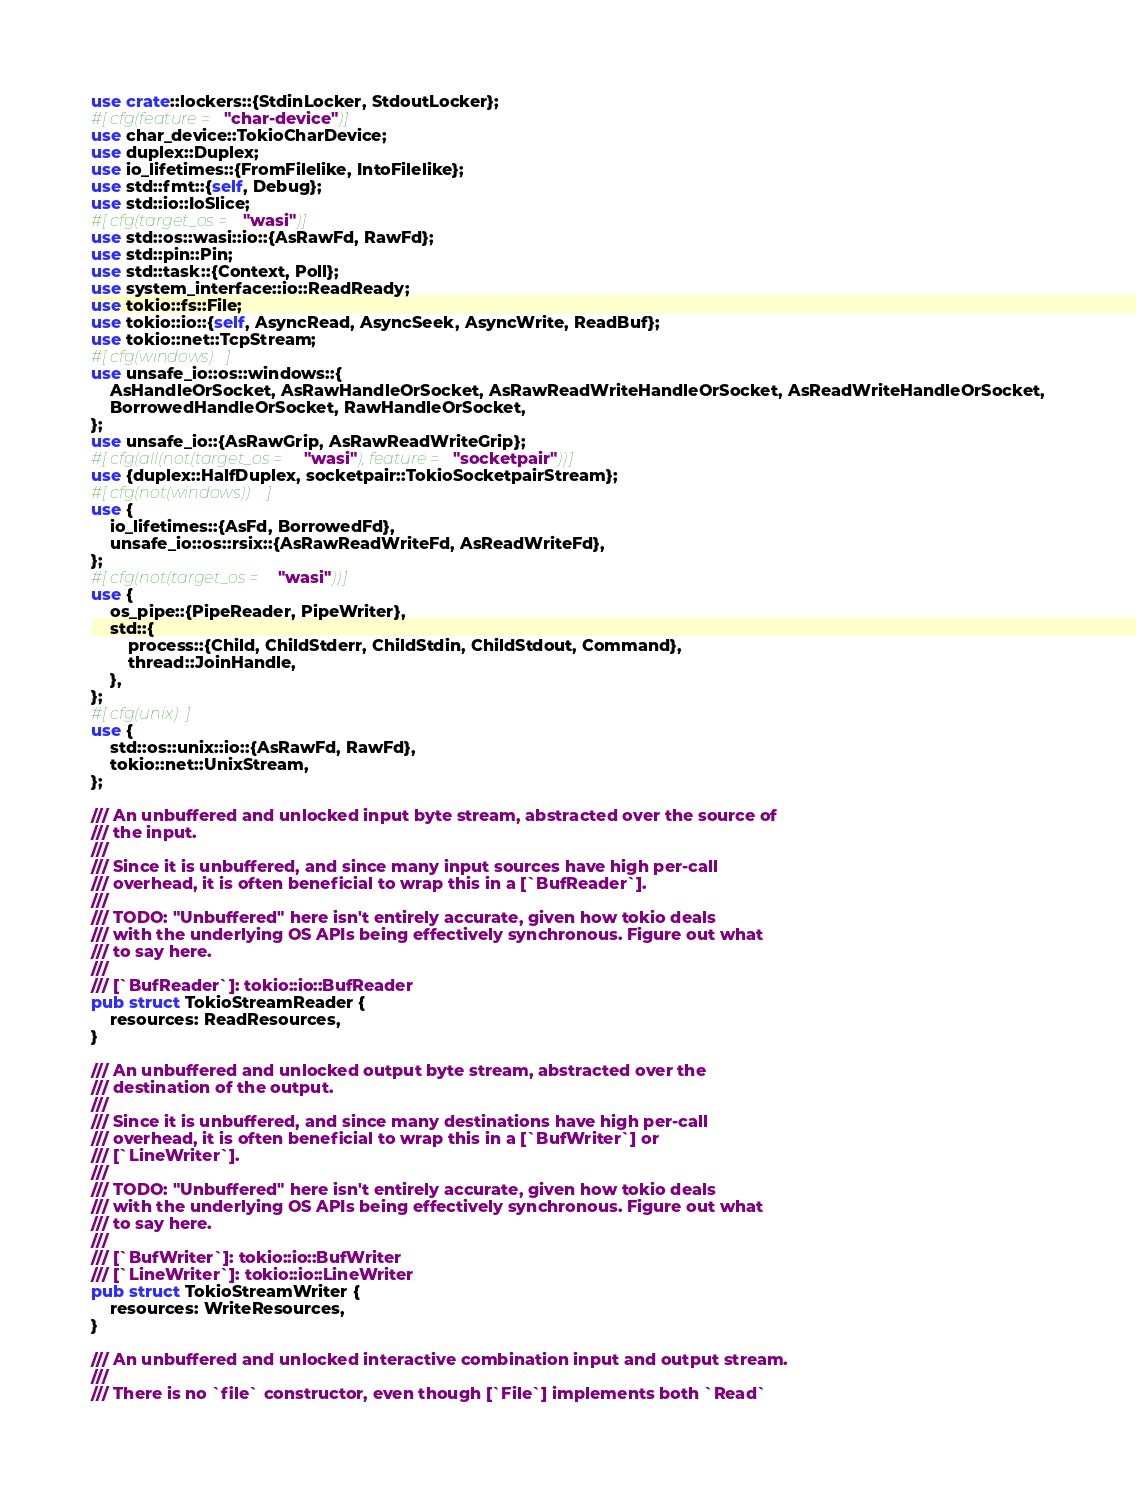<code> <loc_0><loc_0><loc_500><loc_500><_Rust_>use crate::lockers::{StdinLocker, StdoutLocker};
#[cfg(feature = "char-device")]
use char_device::TokioCharDevice;
use duplex::Duplex;
use io_lifetimes::{FromFilelike, IntoFilelike};
use std::fmt::{self, Debug};
use std::io::IoSlice;
#[cfg(target_os = "wasi")]
use std::os::wasi::io::{AsRawFd, RawFd};
use std::pin::Pin;
use std::task::{Context, Poll};
use system_interface::io::ReadReady;
use tokio::fs::File;
use tokio::io::{self, AsyncRead, AsyncSeek, AsyncWrite, ReadBuf};
use tokio::net::TcpStream;
#[cfg(windows)]
use unsafe_io::os::windows::{
    AsHandleOrSocket, AsRawHandleOrSocket, AsRawReadWriteHandleOrSocket, AsReadWriteHandleOrSocket,
    BorrowedHandleOrSocket, RawHandleOrSocket,
};
use unsafe_io::{AsRawGrip, AsRawReadWriteGrip};
#[cfg(all(not(target_os = "wasi"), feature = "socketpair"))]
use {duplex::HalfDuplex, socketpair::TokioSocketpairStream};
#[cfg(not(windows))]
use {
    io_lifetimes::{AsFd, BorrowedFd},
    unsafe_io::os::rsix::{AsRawReadWriteFd, AsReadWriteFd},
};
#[cfg(not(target_os = "wasi"))]
use {
    os_pipe::{PipeReader, PipeWriter},
    std::{
        process::{Child, ChildStderr, ChildStdin, ChildStdout, Command},
        thread::JoinHandle,
    },
};
#[cfg(unix)]
use {
    std::os::unix::io::{AsRawFd, RawFd},
    tokio::net::UnixStream,
};

/// An unbuffered and unlocked input byte stream, abstracted over the source of
/// the input.
///
/// Since it is unbuffered, and since many input sources have high per-call
/// overhead, it is often beneficial to wrap this in a [`BufReader`].
///
/// TODO: "Unbuffered" here isn't entirely accurate, given how tokio deals
/// with the underlying OS APIs being effectively synchronous. Figure out what
/// to say here.
///
/// [`BufReader`]: tokio::io::BufReader
pub struct TokioStreamReader {
    resources: ReadResources,
}

/// An unbuffered and unlocked output byte stream, abstracted over the
/// destination of the output.
///
/// Since it is unbuffered, and since many destinations have high per-call
/// overhead, it is often beneficial to wrap this in a [`BufWriter`] or
/// [`LineWriter`].
///
/// TODO: "Unbuffered" here isn't entirely accurate, given how tokio deals
/// with the underlying OS APIs being effectively synchronous. Figure out what
/// to say here.
///
/// [`BufWriter`]: tokio::io::BufWriter
/// [`LineWriter`]: tokio::io::LineWriter
pub struct TokioStreamWriter {
    resources: WriteResources,
}

/// An unbuffered and unlocked interactive combination input and output stream.
///
/// There is no `file` constructor, even though [`File`] implements both `Read`</code> 